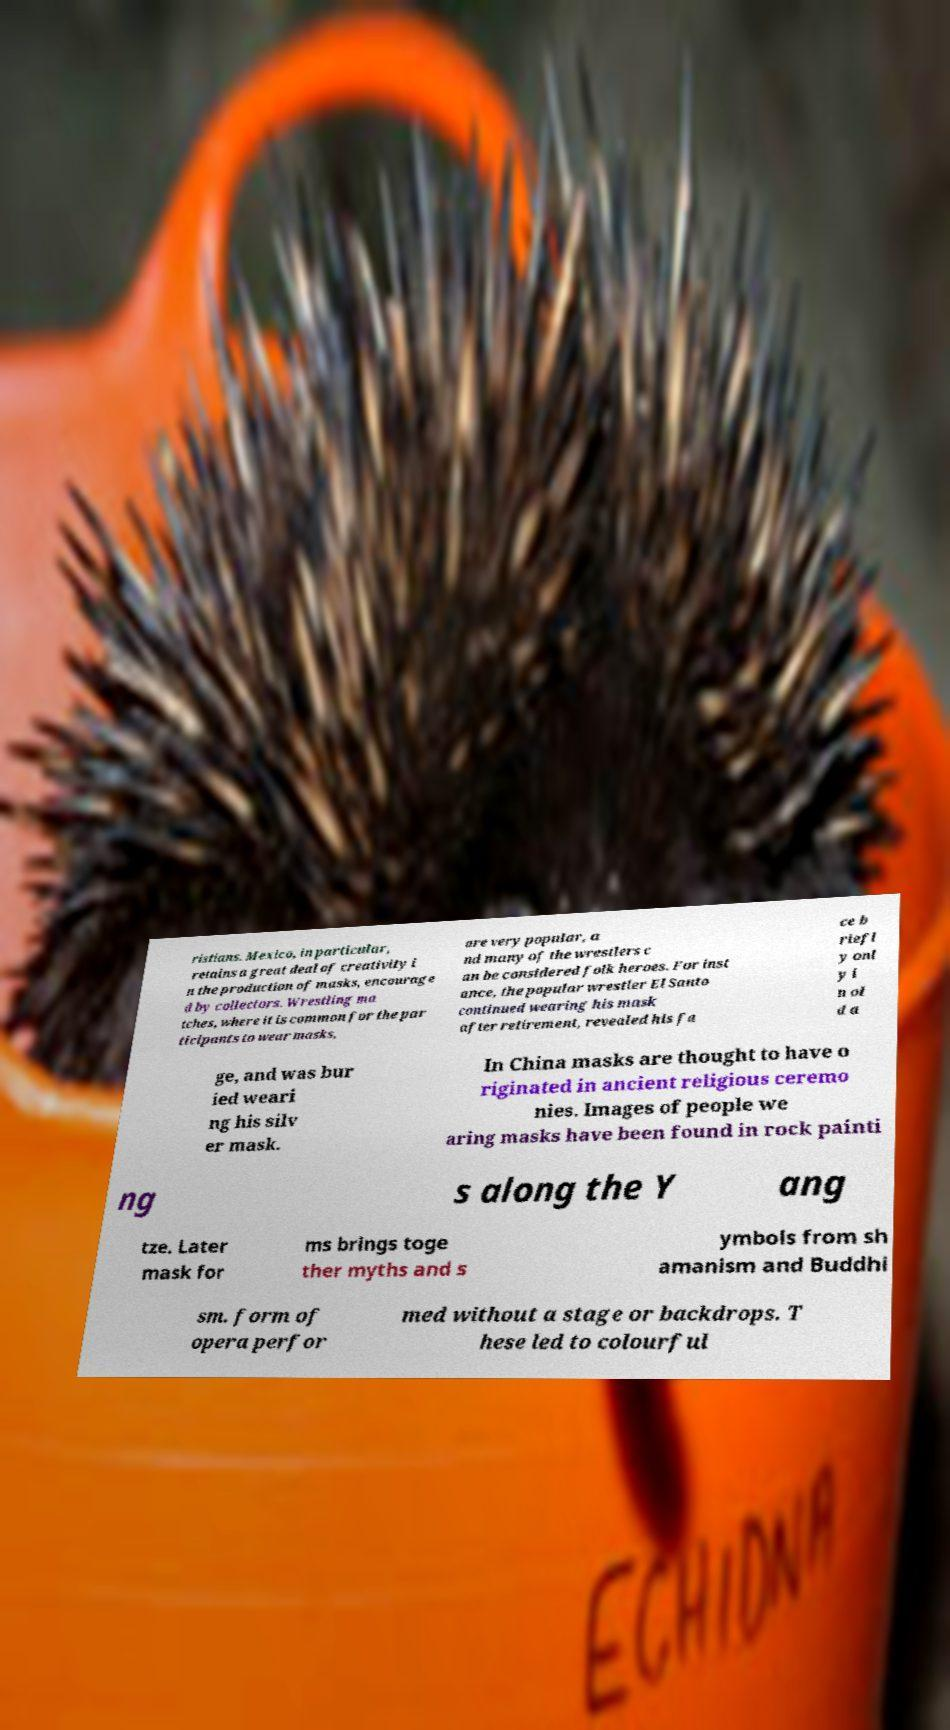Please identify and transcribe the text found in this image. ristians. Mexico, in particular, retains a great deal of creativity i n the production of masks, encourage d by collectors. Wrestling ma tches, where it is common for the par ticipants to wear masks, are very popular, a nd many of the wrestlers c an be considered folk heroes. For inst ance, the popular wrestler El Santo continued wearing his mask after retirement, revealed his fa ce b riefl y onl y i n ol d a ge, and was bur ied weari ng his silv er mask. In China masks are thought to have o riginated in ancient religious ceremo nies. Images of people we aring masks have been found in rock painti ng s along the Y ang tze. Later mask for ms brings toge ther myths and s ymbols from sh amanism and Buddhi sm. form of opera perfor med without a stage or backdrops. T hese led to colourful 